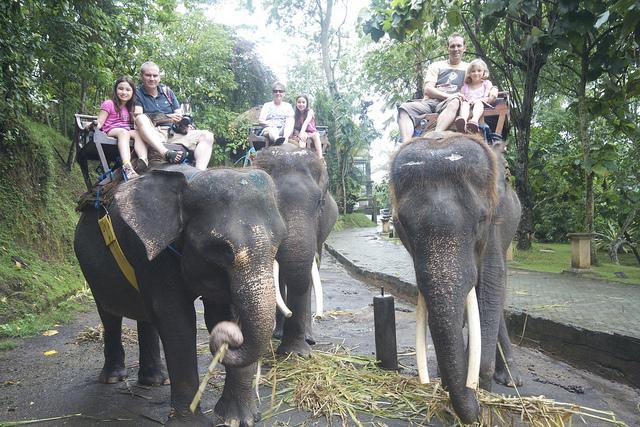Is the man on the left wearing shorts?
Keep it brief. Yes. How many elephants?
Give a very brief answer. 3. What are they riding on?
Short answer required. Elephants. How many people or on each elephant?
Concise answer only. 2. 